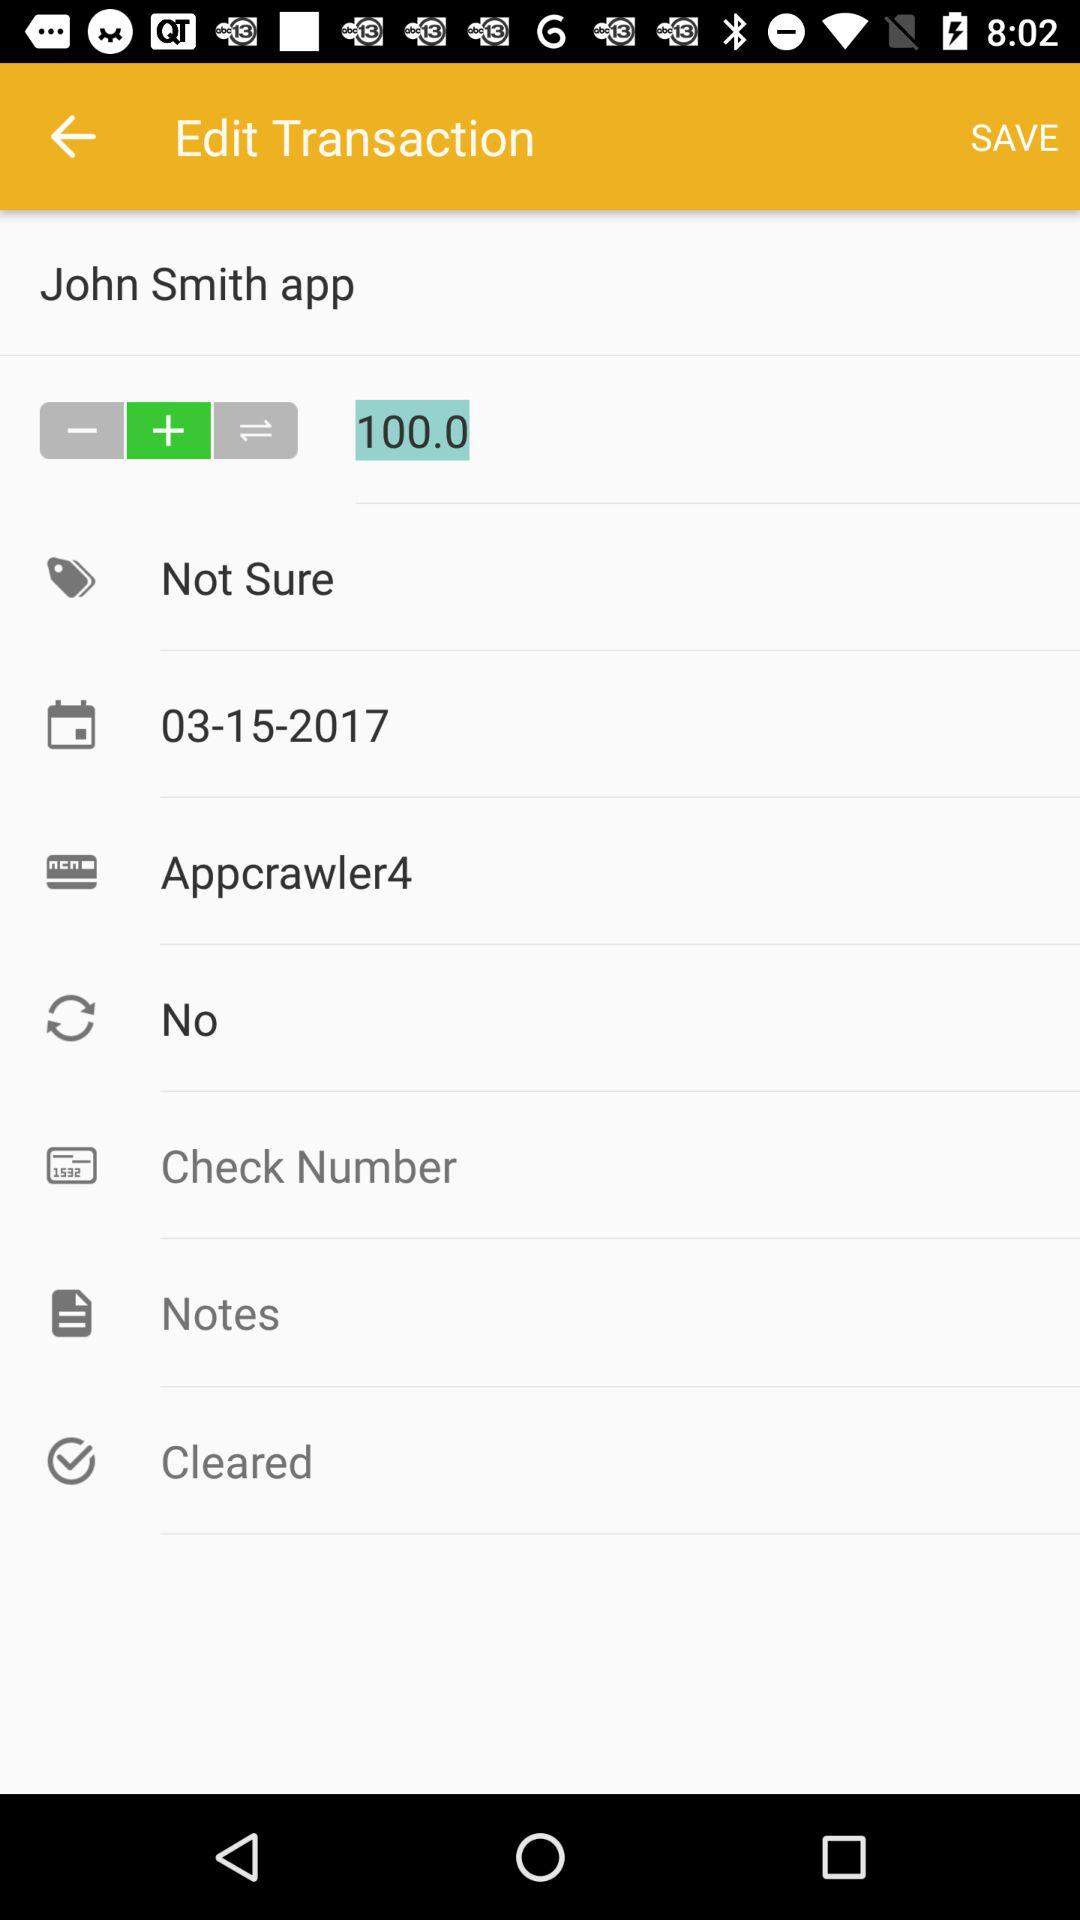What is the date? The date is March 15, 2017. 